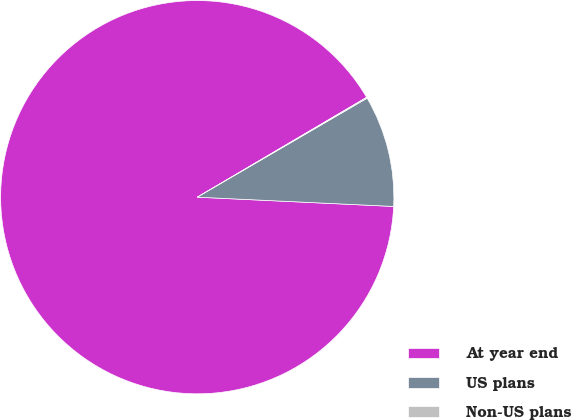<chart> <loc_0><loc_0><loc_500><loc_500><pie_chart><fcel>At year end<fcel>US plans<fcel>Non-US plans<nl><fcel>90.77%<fcel>9.15%<fcel>0.08%<nl></chart> 